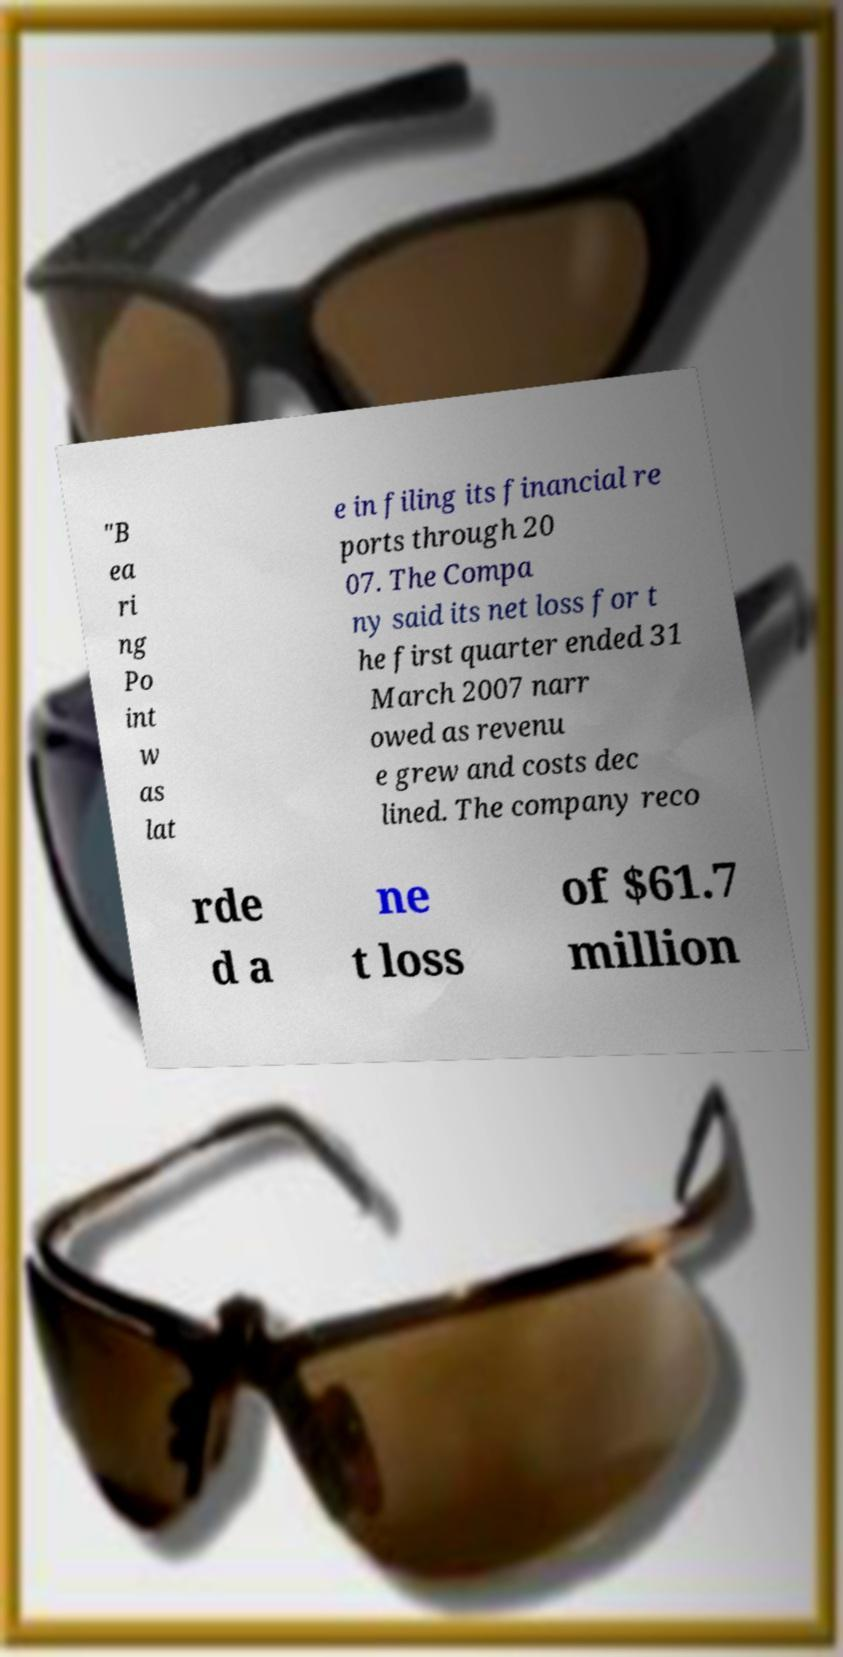Please identify and transcribe the text found in this image. "B ea ri ng Po int w as lat e in filing its financial re ports through 20 07. The Compa ny said its net loss for t he first quarter ended 31 March 2007 narr owed as revenu e grew and costs dec lined. The company reco rde d a ne t loss of $61.7 million 